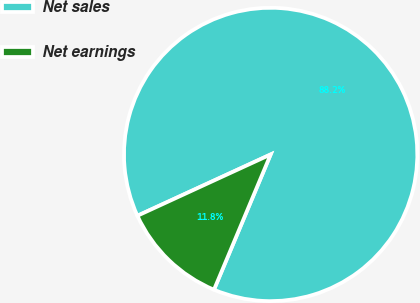Convert chart. <chart><loc_0><loc_0><loc_500><loc_500><pie_chart><fcel>Net sales<fcel>Net earnings<nl><fcel>88.18%<fcel>11.82%<nl></chart> 